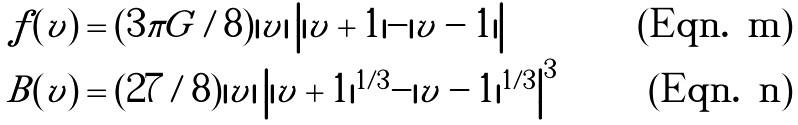Convert formula to latex. <formula><loc_0><loc_0><loc_500><loc_500>\tilde { f } ( v ) & = ( 3 \pi G / 8 ) | v | \left | | v + 1 | - | v - 1 | \right | \\ B ( v ) & = ( 2 7 / 8 ) | v | \left | | v + 1 | ^ { 1 / 3 } - | v - 1 | ^ { 1 / 3 } \right | ^ { 3 }</formula> 